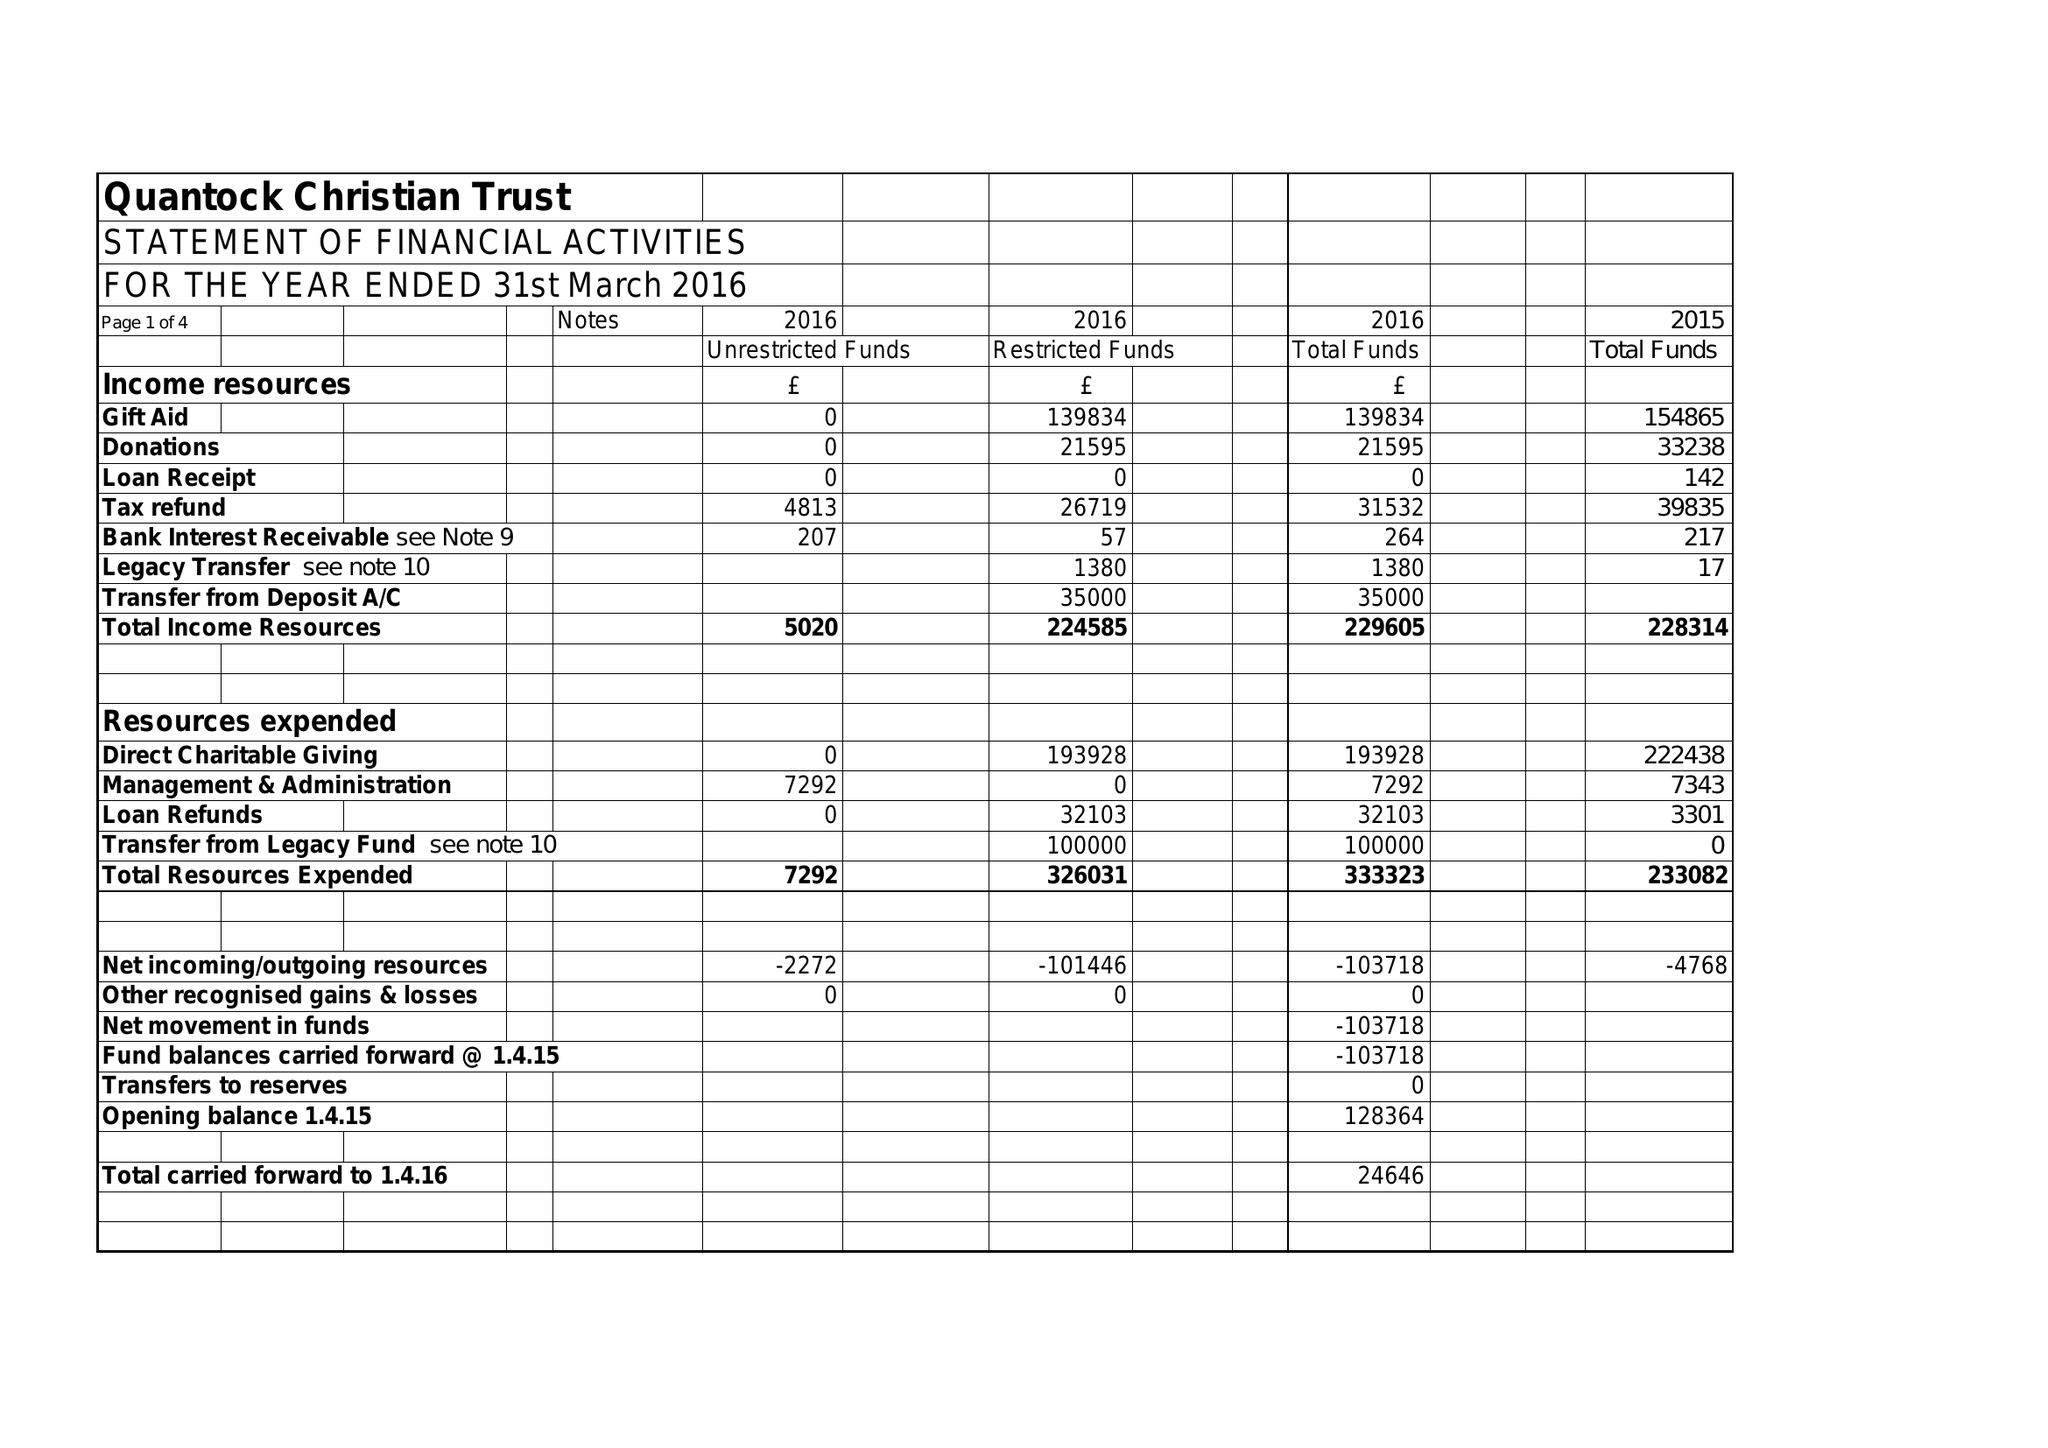What is the value for the income_annually_in_british_pounds?
Answer the question using a single word or phrase. 229605.00 